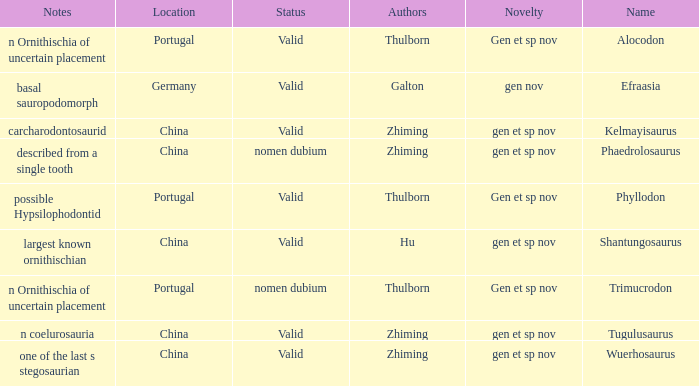What is the Name of the dinosaur, whose notes are, "n ornithischia of uncertain placement"? Alocodon, Trimucrodon. 